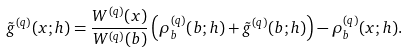<formula> <loc_0><loc_0><loc_500><loc_500>\tilde { g } ^ { ( q ) } ( x ; h ) = \frac { W ^ { ( q ) } ( x ) } { W ^ { ( q ) } ( b ) } \left ( \rho ^ { ( q ) } _ { b } ( b ; h ) + \tilde { g } ^ { ( q ) } ( b ; h ) \right ) - \rho ^ { ( q ) } _ { b } ( x ; h ) .</formula> 